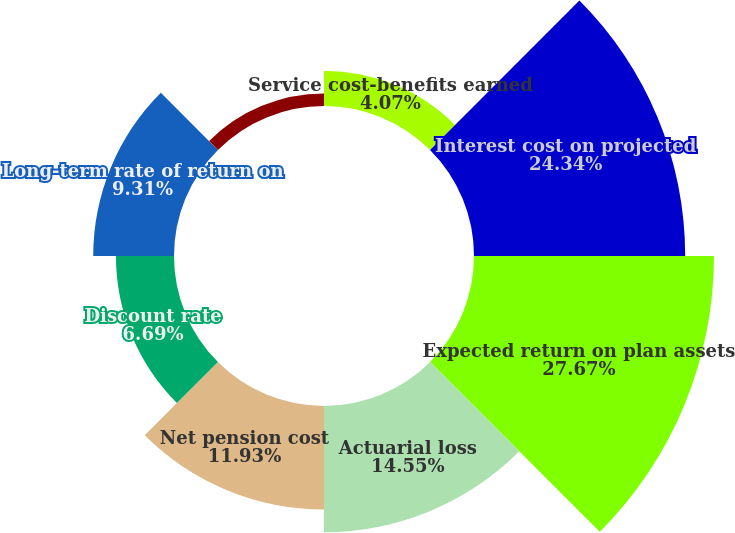Convert chart to OTSL. <chart><loc_0><loc_0><loc_500><loc_500><pie_chart><fcel>Service cost-benefits earned<fcel>Interest cost on projected<fcel>Expected return on plan assets<fcel>Actuarial loss<fcel>Net pension cost<fcel>Discount rate<fcel>Long-term rate of return on<fcel>Long-term rate of compensation<nl><fcel>4.07%<fcel>24.34%<fcel>27.66%<fcel>14.55%<fcel>11.93%<fcel>6.69%<fcel>9.31%<fcel>1.44%<nl></chart> 